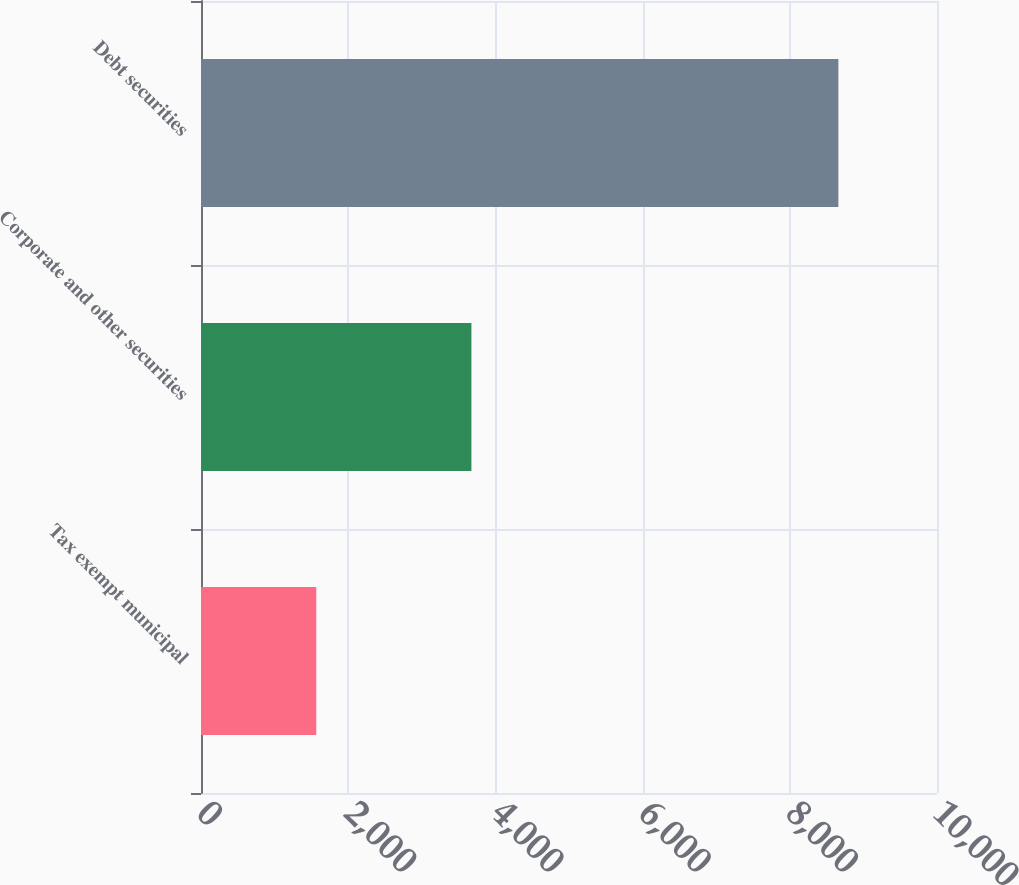Convert chart to OTSL. <chart><loc_0><loc_0><loc_500><loc_500><bar_chart><fcel>Tax exempt municipal<fcel>Corporate and other securities<fcel>Debt securities<nl><fcel>1566<fcel>3674<fcel>8660<nl></chart> 